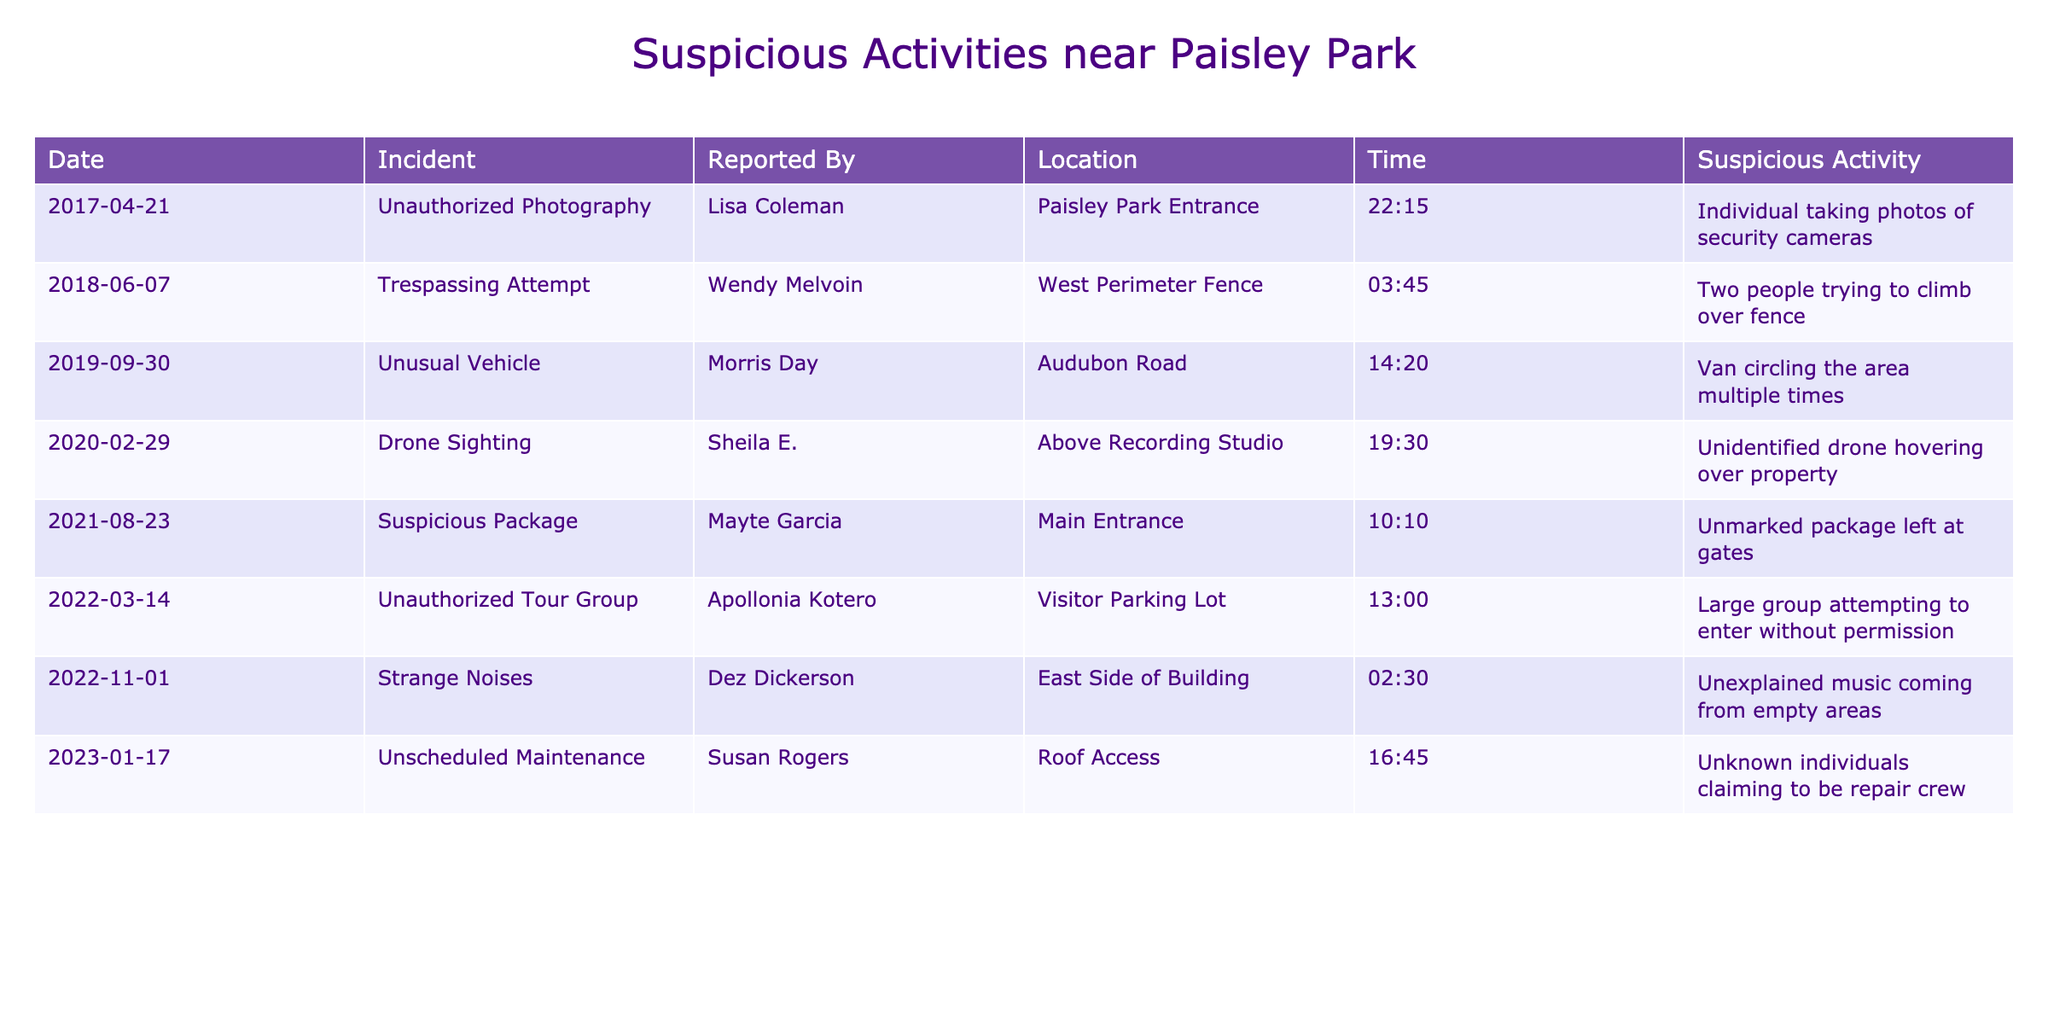What type of suspicious activity was reported on February 29, 2020? The table shows that on February 29, 2020, a drone sighting was reported, which was classified as suspicious activity.
Answer: Drone Sighting How many total incidents of suspicious activities have been reported? By counting the entries in the table, there are a total of 8 reported incidents listed.
Answer: 8 Which incident was reported at the latest date, and what was the suspicious activity? The latest incident date is January 17, 2023, which involved unscheduled maintenance by unknown individuals claiming to be a repair crew.
Answer: Unscheduled Maintenance What was the reported time for the suspicious package incident? The suspicious package incident was reported at 10:10 AM on August 23, 2021, according to the table data provided.
Answer: 10:10 AM Was there an instance of unauthorized activity before 2019? Yes, there were two instances of unauthorized activities before 2019; one in 2017 and another in 2018.
Answer: Yes Who reported the unusual vehicle sighting, and what time was it reported? Morris Day reported the unusual vehicle sighting at 14:20 (2:20 PM) on September 30, 2019.
Answer: Morris Day at 14:20 What is the difference in reporting times between the suspicious package and the drone sighting? The suspicious package was reported at 10:10 AM, and the drone sighting was reported at 19:30 (7:30 PM). The difference is 9 hours and 20 minutes.
Answer: 9 hours and 20 minutes How many reported incidents involved an element of trespassing? Two incidents in the table directly involved elements of trespassing: the unauthorized photography in 2017 and the trespassing attempt in 2018.
Answer: 2 Which type of incident had the earliest report date, and what was it? The earliest report date listed is April 21, 2017, regarding unauthorized photography at the Paisley Park entrance.
Answer: Unauthorized Photography Did any of the reported suspicious activities involve a specific person of interest from Prince's inner circle? Yes, multiple incidents involved individuals closely associated with Prince, such as Wendy Melvoin, Lisa Coleman, and others.
Answer: Yes 